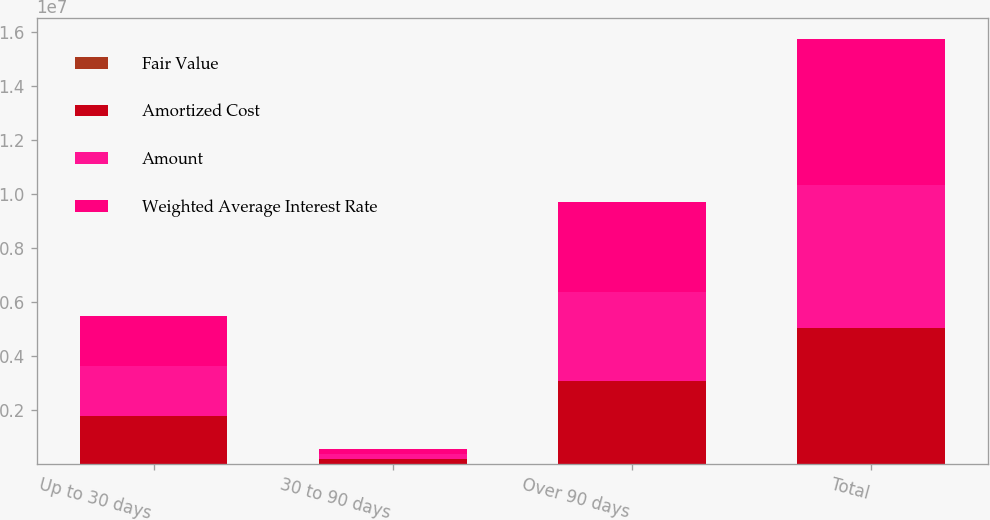Convert chart to OTSL. <chart><loc_0><loc_0><loc_500><loc_500><stacked_bar_chart><ecel><fcel>Up to 30 days<fcel>30 to 90 days<fcel>Over 90 days<fcel>Total<nl><fcel>Fair Value<fcel>0.65<fcel>1.53<fcel>1.08<fcel>0.95<nl><fcel>Amortized Cost<fcel>1.76709e+06<fcel>175214<fcel>3.0732e+06<fcel>5.0155e+06<nl><fcel>Amount<fcel>1.84807e+06<fcel>187212<fcel>3.28328e+06<fcel>5.31857e+06<nl><fcel>Weighted Average Interest Rate<fcel>1.86381e+06<fcel>190203<fcel>3.33573e+06<fcel>5.38974e+06<nl></chart> 